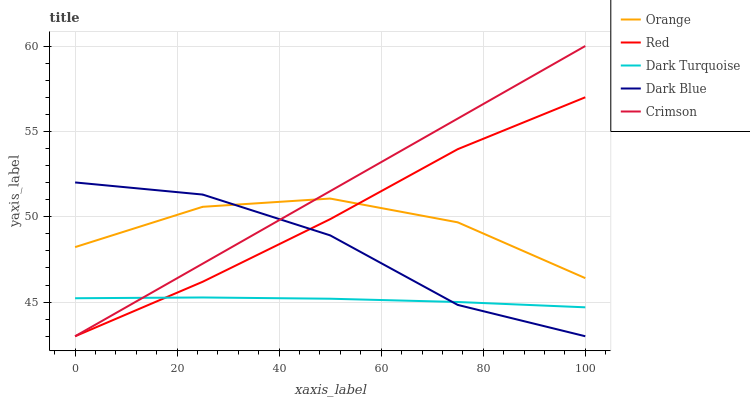Does Dark Turquoise have the minimum area under the curve?
Answer yes or no. Yes. Does Crimson have the maximum area under the curve?
Answer yes or no. Yes. Does Crimson have the minimum area under the curve?
Answer yes or no. No. Does Dark Turquoise have the maximum area under the curve?
Answer yes or no. No. Is Crimson the smoothest?
Answer yes or no. Yes. Is Orange the roughest?
Answer yes or no. Yes. Is Dark Turquoise the smoothest?
Answer yes or no. No. Is Dark Turquoise the roughest?
Answer yes or no. No. Does Crimson have the lowest value?
Answer yes or no. Yes. Does Dark Turquoise have the lowest value?
Answer yes or no. No. Does Crimson have the highest value?
Answer yes or no. Yes. Does Dark Turquoise have the highest value?
Answer yes or no. No. Is Dark Turquoise less than Orange?
Answer yes or no. Yes. Is Orange greater than Dark Turquoise?
Answer yes or no. Yes. Does Dark Blue intersect Red?
Answer yes or no. Yes. Is Dark Blue less than Red?
Answer yes or no. No. Is Dark Blue greater than Red?
Answer yes or no. No. Does Dark Turquoise intersect Orange?
Answer yes or no. No. 